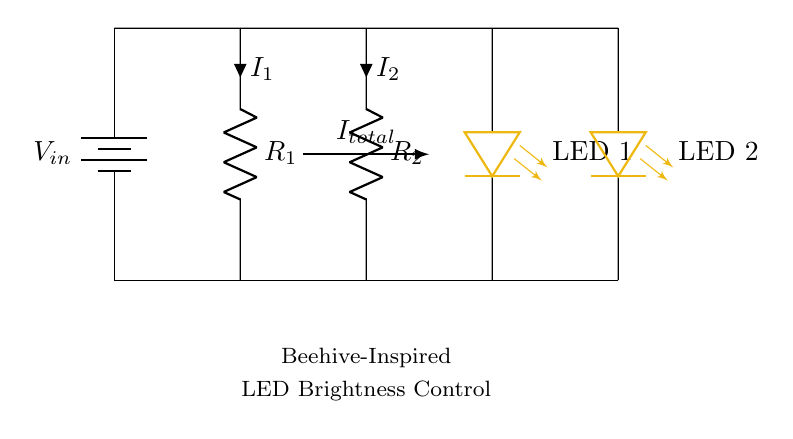What is the type of this circuit? This circuit is a Current Divider because the total current flowing into the circuit divides between the parallel resistors, leading to different currents through each path.
Answer: Current Divider What are the resistors' values? The values of the resistors are not indicated in the diagram; therefore, we cannot determine their exact values without additional specifications.
Answer: Not specified How many LEDs are in the circuit? There are two LEDs connected in parallel to the current divider circuit, as shown in the diagram.
Answer: Two What color are the LEDs? The LEDs are colored honey gold, which is specified in the diagram for aesthetic purposes in the beehive-inspired art installation.
Answer: Honey gold What is the relationship between total current and the branch currents? The total current entering the circuit divides into different paths as I total equals I 1 plus I 2, according to Kirchhoff's Current Law.
Answer: I total = I 1 + I 2 If R1 is halved, what happens to I1? If R1 is halved while the total voltage remains constant, the current through R1 (I1) increases because current and resistance are inversely related in a constant voltage circuit.
Answer: Increases What could be an artistic reason for using different resistor values? Using different resistor values can create varied brightness levels in the LEDs, symbolizing the diversity and complexity found in a beehive, enhancing the artistic vision.
Answer: Varied brightness levels 